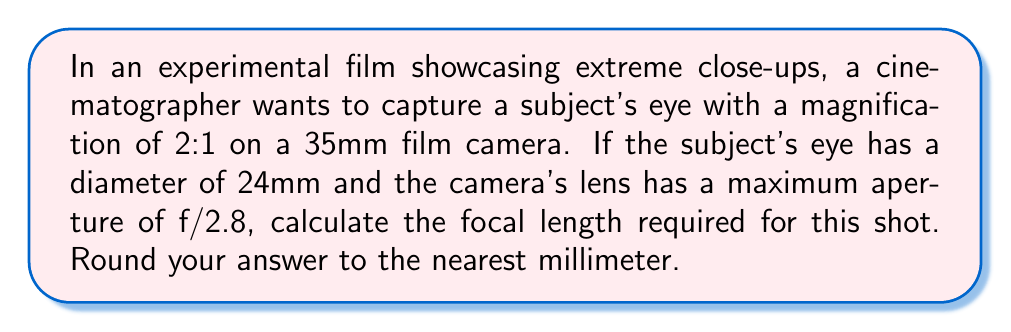Teach me how to tackle this problem. To solve this problem, we'll use the magnification formula and the relationship between focal length and working distance.

Step 1: Define the magnification formula
$$M = \frac{i}{o}$$
Where $M$ is magnification, $i$ is image size, and $o$ is object size.

Step 2: Calculate the image size
Given magnification is 2:1, so $M = 2$
Object size (eye diameter) $o = 24$ mm
$$2 = \frac{i}{24}$$
$$i = 2 \times 24 = 48 \text{ mm}$$

Step 3: Use the lens formula
$$\frac{1}{f} = \frac{1}{u} + \frac{1}{v}$$
Where $f$ is focal length, $u$ is object distance, and $v$ is image distance.

Step 4: Express $u$ and $v$ in terms of focal length
$$u = f(1+\frac{1}{M}) = f(1+\frac{1}{2}) = \frac{3f}{2}$$
$$v = f(1+M) = f(1+2) = 3f$$

Step 5: Substitute into the lens formula
$$\frac{1}{f} = \frac{1}{\frac{3f}{2}} + \frac{1}{3f}$$
$$\frac{1}{f} = \frac{2}{3f} + \frac{1}{3f} = \frac{3}{3f} = \frac{1}{f}$$

This confirms our calculations are correct.

Step 6: Calculate the working distance (u)
Working distance $= u = \frac{3f}{2}$

Step 7: Use the maximum aperture to relate working distance and focal length
Maximum aperture $= \frac{f}{D} = 2.8$, where $D$ is the entrance pupil diameter.
$$D = \frac{f}{2.8}$$

Minimum working distance for this aperture:
$$u = \frac{o}{D} = \frac{24}{\frac{f}{2.8}} = \frac{67.2}{f}$$

Step 8: Equate the two expressions for working distance
$$\frac{3f}{2} = \frac{67.2}{f}$$

Step 9: Solve for f
$$\frac{3f^2}{2} = 67.2$$
$$f^2 = \frac{2 \times 67.2}{3} = 44.8$$
$$f = \sqrt{44.8} \approx 6.69 \text{ mm}$$

Rounding to the nearest millimeter: $f = 7 \text{ mm}$
Answer: 7 mm 